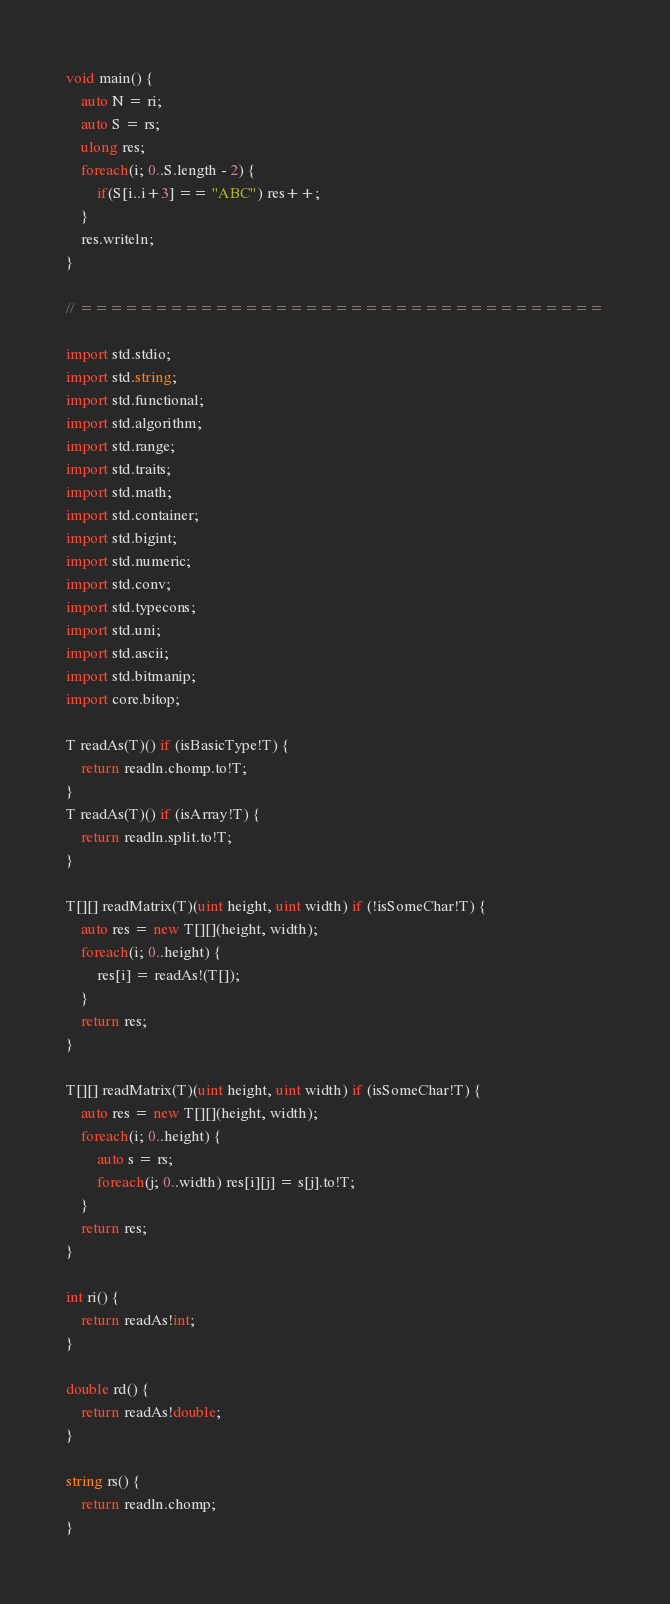<code> <loc_0><loc_0><loc_500><loc_500><_D_>void main() {
	auto N = ri;
	auto S = rs;
	ulong res;
	foreach(i; 0..S.length - 2) {
		if(S[i..i+3] == "ABC") res++;
	}
	res.writeln;
}

// ===================================

import std.stdio;
import std.string;
import std.functional;
import std.algorithm;
import std.range;
import std.traits;
import std.math;
import std.container;
import std.bigint;
import std.numeric;
import std.conv;
import std.typecons;
import std.uni;
import std.ascii;
import std.bitmanip;
import core.bitop;

T readAs(T)() if (isBasicType!T) {
	return readln.chomp.to!T;
}
T readAs(T)() if (isArray!T) {
	return readln.split.to!T;
}

T[][] readMatrix(T)(uint height, uint width) if (!isSomeChar!T) {
	auto res = new T[][](height, width);
	foreach(i; 0..height) {
		res[i] = readAs!(T[]);
	}
	return res;
}

T[][] readMatrix(T)(uint height, uint width) if (isSomeChar!T) {
	auto res = new T[][](height, width);
	foreach(i; 0..height) {
		auto s = rs;
		foreach(j; 0..width) res[i][j] = s[j].to!T;
	}
	return res;
}

int ri() {
	return readAs!int;
}

double rd() {
	return readAs!double;
}

string rs() {
	return readln.chomp;
}</code> 